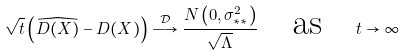Convert formula to latex. <formula><loc_0><loc_0><loc_500><loc_500>\sqrt { t } \left ( \widehat { D ( X ) } - D ( X ) \right ) \stackrel { \mathcal { D } } { \longrightarrow } \frac { N \left ( 0 , \sigma _ { * * } ^ { 2 } \right ) } { \sqrt { \Lambda } } \quad \text {as} \quad t \rightarrow \infty</formula> 